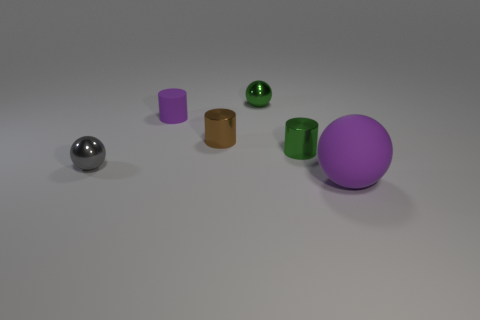There is a green ball that is behind the big rubber object; how many small metallic balls are in front of it?
Keep it short and to the point. 1. There is a purple object that is to the left of the purple rubber object that is in front of the tiny brown metallic thing that is behind the small green metal cylinder; how big is it?
Provide a succinct answer. Small. There is a matte object to the left of the green metal sphere; is its color the same as the large ball?
Give a very brief answer. Yes. The green thing that is the same shape as the big purple matte object is what size?
Provide a short and direct response. Small. What number of things are balls that are behind the big purple sphere or metal cylinders in front of the purple matte cylinder?
Your response must be concise. 4. What is the shape of the metallic object that is left of the purple object left of the big object?
Your answer should be compact. Sphere. Are there any other things of the same color as the large sphere?
Keep it short and to the point. Yes. Is there any other thing that is the same size as the purple sphere?
Offer a terse response. No. How many objects are small blue rubber objects or shiny objects?
Your answer should be compact. 4. Are there any other cylinders that have the same size as the green metallic cylinder?
Give a very brief answer. Yes. 